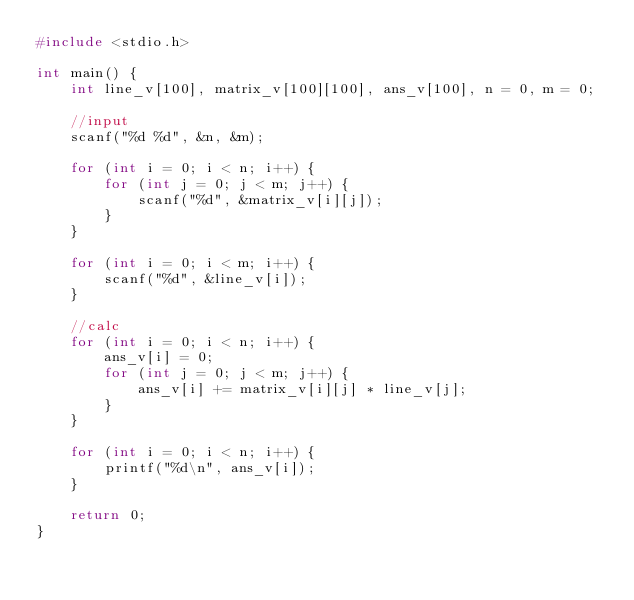<code> <loc_0><loc_0><loc_500><loc_500><_C_>#include <stdio.h>

int main() {
	int line_v[100], matrix_v[100][100], ans_v[100], n = 0, m = 0;

	//input
	scanf("%d %d", &n, &m);

	for (int i = 0; i < n; i++) {
		for (int j = 0; j < m; j++) {
			scanf("%d", &matrix_v[i][j]);
		}
	}

	for (int i = 0; i < m; i++) {
		scanf("%d", &line_v[i]);
	}

	//calc
	for (int i = 0; i < n; i++) {
		ans_v[i] = 0;
		for (int j = 0; j < m; j++) {
			ans_v[i] += matrix_v[i][j] * line_v[j];
		}
	}

	for (int i = 0; i < n; i++) {
		printf("%d\n", ans_v[i]);
	}

	return 0;
}
</code> 